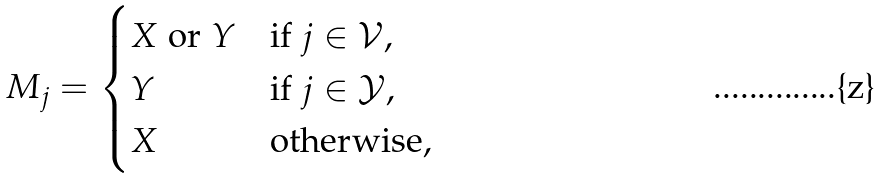Convert formula to latex. <formula><loc_0><loc_0><loc_500><loc_500>M _ { j } = \begin{cases} X \text { or } Y & \text {if } j \in \mathcal { V } , \\ Y & \text {if } j \in \mathcal { Y } , \\ X & \text {otherwise,} \end{cases}</formula> 